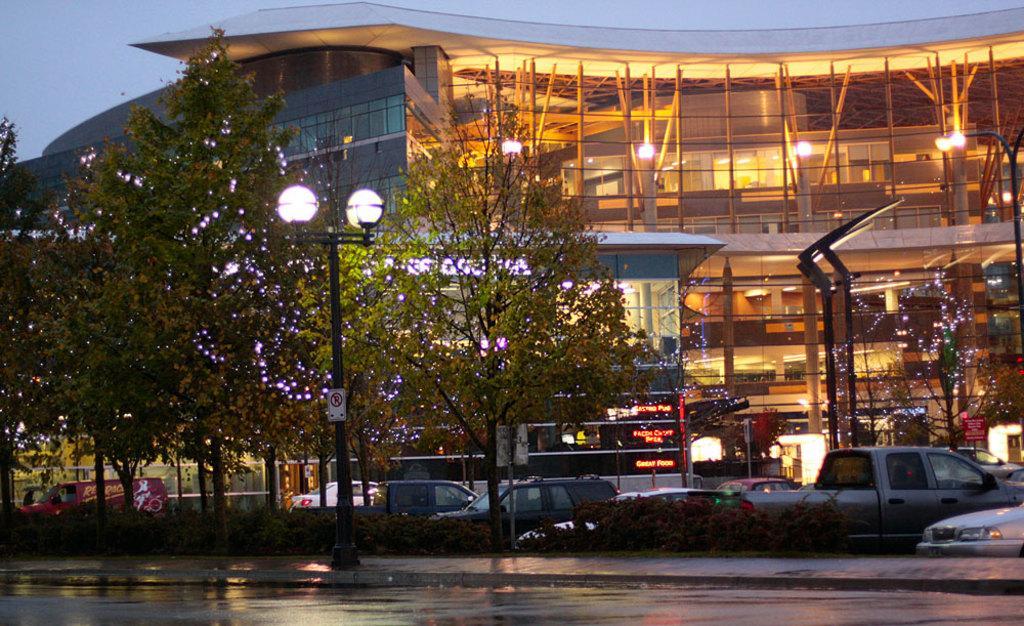In one or two sentences, can you explain what this image depicts? In this image there are buildings, in front of the building there are few vehicles moving on the road and there are trees and street lights. In the background there is the sky. 